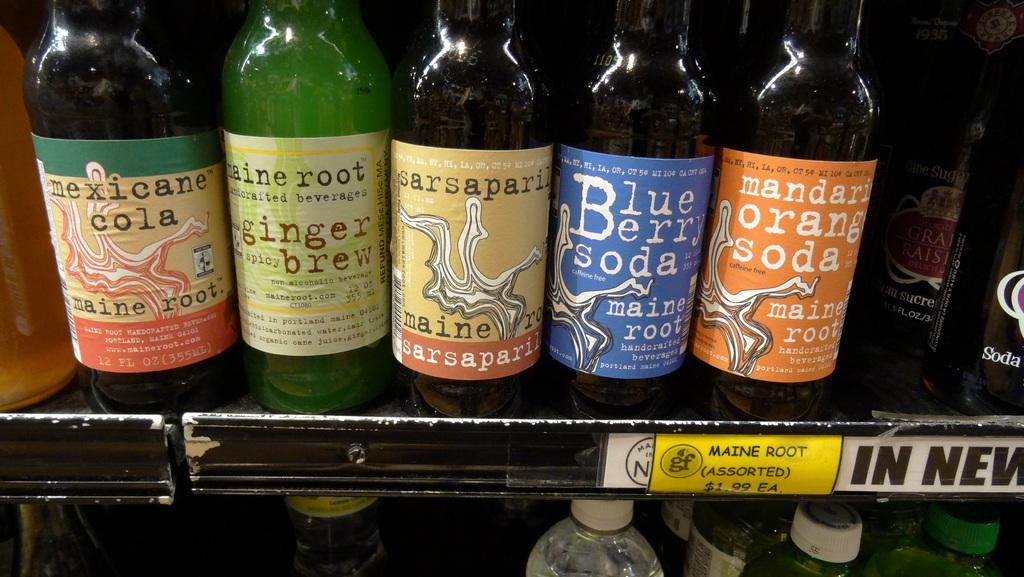<image>
Relay a brief, clear account of the picture shown. Five soda bottles on a shelf made by maine root. 